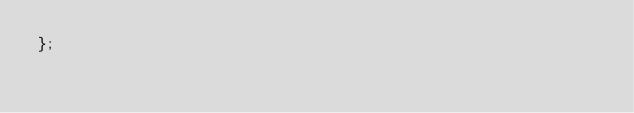<code> <loc_0><loc_0><loc_500><loc_500><_TypeScript_>};
</code> 